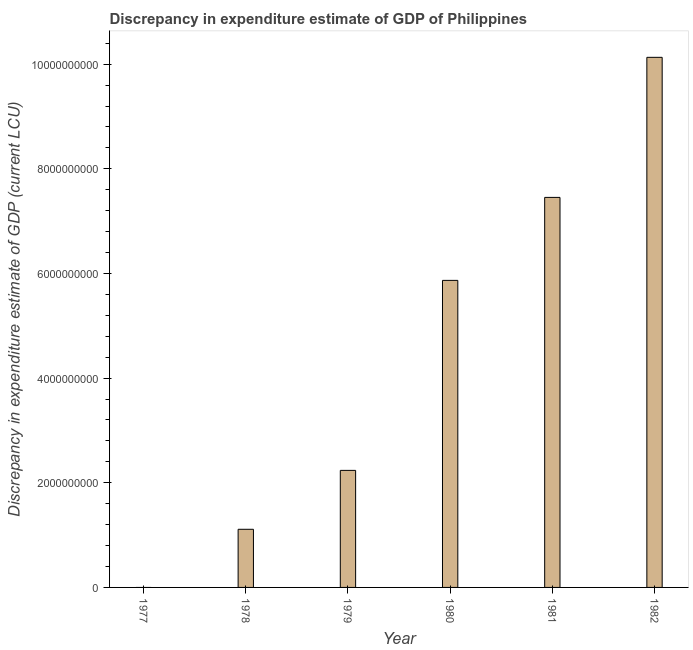What is the title of the graph?
Provide a succinct answer. Discrepancy in expenditure estimate of GDP of Philippines. What is the label or title of the X-axis?
Provide a succinct answer. Year. What is the label or title of the Y-axis?
Offer a very short reply. Discrepancy in expenditure estimate of GDP (current LCU). What is the discrepancy in expenditure estimate of gdp in 1981?
Ensure brevity in your answer.  7.45e+09. Across all years, what is the maximum discrepancy in expenditure estimate of gdp?
Your answer should be very brief. 1.01e+1. Across all years, what is the minimum discrepancy in expenditure estimate of gdp?
Ensure brevity in your answer.  0. What is the sum of the discrepancy in expenditure estimate of gdp?
Your answer should be very brief. 2.68e+1. What is the difference between the discrepancy in expenditure estimate of gdp in 1980 and 1982?
Your answer should be very brief. -4.26e+09. What is the average discrepancy in expenditure estimate of gdp per year?
Your answer should be compact. 4.47e+09. What is the median discrepancy in expenditure estimate of gdp?
Offer a terse response. 4.05e+09. What is the ratio of the discrepancy in expenditure estimate of gdp in 1978 to that in 1980?
Offer a very short reply. 0.19. Is the discrepancy in expenditure estimate of gdp in 1979 less than that in 1981?
Ensure brevity in your answer.  Yes. What is the difference between the highest and the second highest discrepancy in expenditure estimate of gdp?
Your answer should be compact. 2.68e+09. Is the sum of the discrepancy in expenditure estimate of gdp in 1978 and 1979 greater than the maximum discrepancy in expenditure estimate of gdp across all years?
Give a very brief answer. No. What is the difference between the highest and the lowest discrepancy in expenditure estimate of gdp?
Make the answer very short. 1.01e+1. Are all the bars in the graph horizontal?
Provide a succinct answer. No. How many years are there in the graph?
Offer a terse response. 6. Are the values on the major ticks of Y-axis written in scientific E-notation?
Offer a very short reply. No. What is the Discrepancy in expenditure estimate of GDP (current LCU) of 1977?
Ensure brevity in your answer.  0. What is the Discrepancy in expenditure estimate of GDP (current LCU) of 1978?
Provide a succinct answer. 1.11e+09. What is the Discrepancy in expenditure estimate of GDP (current LCU) of 1979?
Your answer should be very brief. 2.24e+09. What is the Discrepancy in expenditure estimate of GDP (current LCU) in 1980?
Make the answer very short. 5.87e+09. What is the Discrepancy in expenditure estimate of GDP (current LCU) in 1981?
Offer a very short reply. 7.45e+09. What is the Discrepancy in expenditure estimate of GDP (current LCU) in 1982?
Offer a very short reply. 1.01e+1. What is the difference between the Discrepancy in expenditure estimate of GDP (current LCU) in 1978 and 1979?
Ensure brevity in your answer.  -1.13e+09. What is the difference between the Discrepancy in expenditure estimate of GDP (current LCU) in 1978 and 1980?
Ensure brevity in your answer.  -4.76e+09. What is the difference between the Discrepancy in expenditure estimate of GDP (current LCU) in 1978 and 1981?
Make the answer very short. -6.34e+09. What is the difference between the Discrepancy in expenditure estimate of GDP (current LCU) in 1978 and 1982?
Provide a short and direct response. -9.02e+09. What is the difference between the Discrepancy in expenditure estimate of GDP (current LCU) in 1979 and 1980?
Keep it short and to the point. -3.63e+09. What is the difference between the Discrepancy in expenditure estimate of GDP (current LCU) in 1979 and 1981?
Make the answer very short. -5.22e+09. What is the difference between the Discrepancy in expenditure estimate of GDP (current LCU) in 1979 and 1982?
Provide a short and direct response. -7.89e+09. What is the difference between the Discrepancy in expenditure estimate of GDP (current LCU) in 1980 and 1981?
Offer a terse response. -1.59e+09. What is the difference between the Discrepancy in expenditure estimate of GDP (current LCU) in 1980 and 1982?
Offer a very short reply. -4.26e+09. What is the difference between the Discrepancy in expenditure estimate of GDP (current LCU) in 1981 and 1982?
Offer a very short reply. -2.68e+09. What is the ratio of the Discrepancy in expenditure estimate of GDP (current LCU) in 1978 to that in 1979?
Your answer should be very brief. 0.5. What is the ratio of the Discrepancy in expenditure estimate of GDP (current LCU) in 1978 to that in 1980?
Offer a very short reply. 0.19. What is the ratio of the Discrepancy in expenditure estimate of GDP (current LCU) in 1978 to that in 1981?
Give a very brief answer. 0.15. What is the ratio of the Discrepancy in expenditure estimate of GDP (current LCU) in 1978 to that in 1982?
Your answer should be very brief. 0.11. What is the ratio of the Discrepancy in expenditure estimate of GDP (current LCU) in 1979 to that in 1980?
Your answer should be compact. 0.38. What is the ratio of the Discrepancy in expenditure estimate of GDP (current LCU) in 1979 to that in 1982?
Make the answer very short. 0.22. What is the ratio of the Discrepancy in expenditure estimate of GDP (current LCU) in 1980 to that in 1981?
Provide a succinct answer. 0.79. What is the ratio of the Discrepancy in expenditure estimate of GDP (current LCU) in 1980 to that in 1982?
Offer a terse response. 0.58. What is the ratio of the Discrepancy in expenditure estimate of GDP (current LCU) in 1981 to that in 1982?
Your answer should be compact. 0.74. 